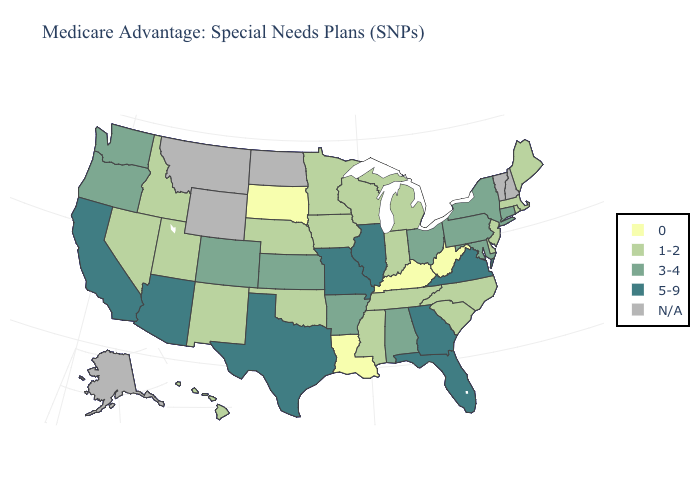What is the value of Massachusetts?
Quick response, please. 1-2. Name the states that have a value in the range 3-4?
Give a very brief answer. Alabama, Arkansas, Colorado, Connecticut, Kansas, Maryland, New York, Ohio, Oregon, Pennsylvania, Washington. Does Arkansas have the highest value in the South?
Give a very brief answer. No. Among the states that border Pennsylvania , does Delaware have the lowest value?
Give a very brief answer. No. What is the value of Virginia?
Short answer required. 5-9. Name the states that have a value in the range 5-9?
Write a very short answer. Arizona, California, Florida, Georgia, Illinois, Missouri, Texas, Virginia. Does the map have missing data?
Concise answer only. Yes. What is the value of South Carolina?
Answer briefly. 1-2. Is the legend a continuous bar?
Be succinct. No. Name the states that have a value in the range 5-9?
Short answer required. Arizona, California, Florida, Georgia, Illinois, Missouri, Texas, Virginia. Does Missouri have the highest value in the USA?
Keep it brief. Yes. Which states have the lowest value in the USA?
Give a very brief answer. Kentucky, Louisiana, South Dakota, West Virginia. Which states hav the highest value in the South?
Write a very short answer. Florida, Georgia, Texas, Virginia. Among the states that border Washington , does Idaho have the highest value?
Answer briefly. No. What is the value of California?
Be succinct. 5-9. 